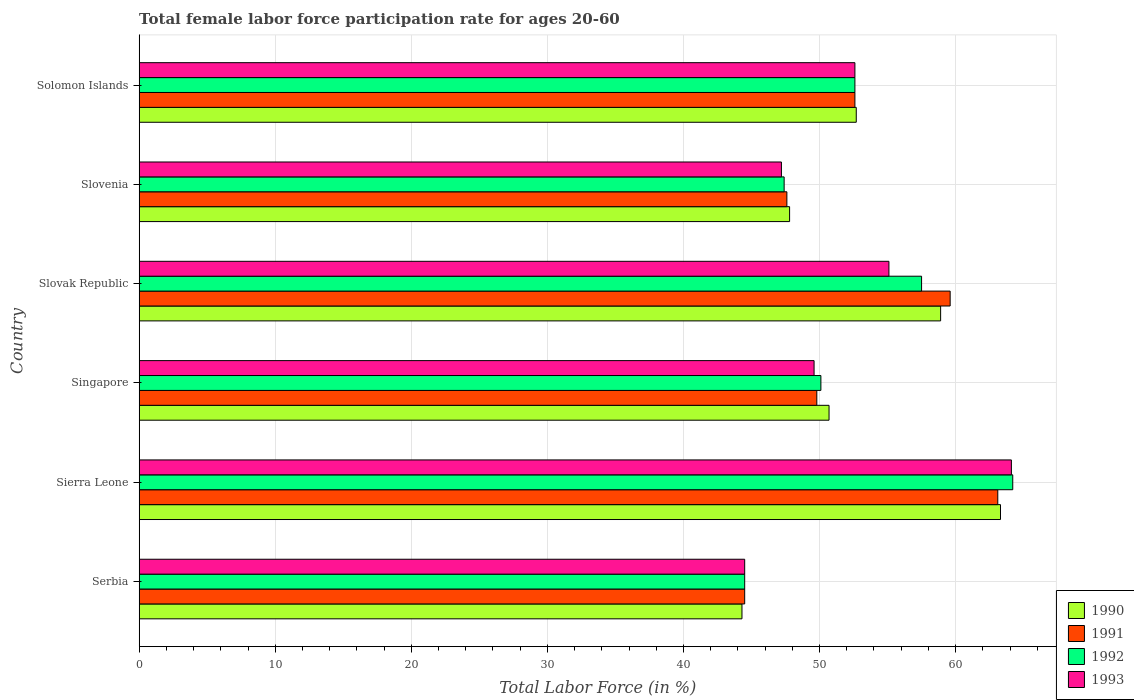How many bars are there on the 2nd tick from the top?
Your response must be concise. 4. What is the label of the 5th group of bars from the top?
Provide a succinct answer. Sierra Leone. What is the female labor force participation rate in 1991 in Singapore?
Provide a short and direct response. 49.8. Across all countries, what is the maximum female labor force participation rate in 1992?
Give a very brief answer. 64.2. Across all countries, what is the minimum female labor force participation rate in 1990?
Ensure brevity in your answer.  44.3. In which country was the female labor force participation rate in 1992 maximum?
Provide a short and direct response. Sierra Leone. In which country was the female labor force participation rate in 1990 minimum?
Give a very brief answer. Serbia. What is the total female labor force participation rate in 1991 in the graph?
Keep it short and to the point. 317.2. What is the difference between the female labor force participation rate in 1992 in Serbia and that in Sierra Leone?
Keep it short and to the point. -19.7. What is the difference between the female labor force participation rate in 1990 in Serbia and the female labor force participation rate in 1992 in Sierra Leone?
Provide a short and direct response. -19.9. What is the average female labor force participation rate in 1992 per country?
Make the answer very short. 52.72. What is the difference between the female labor force participation rate in 1990 and female labor force participation rate in 1991 in Serbia?
Give a very brief answer. -0.2. What is the ratio of the female labor force participation rate in 1993 in Sierra Leone to that in Solomon Islands?
Your response must be concise. 1.22. Is the female labor force participation rate in 1990 in Sierra Leone less than that in Solomon Islands?
Your answer should be compact. No. Is the difference between the female labor force participation rate in 1990 in Singapore and Slovenia greater than the difference between the female labor force participation rate in 1991 in Singapore and Slovenia?
Make the answer very short. Yes. What is the difference between the highest and the second highest female labor force participation rate in 1991?
Make the answer very short. 3.5. What is the difference between the highest and the lowest female labor force participation rate in 1990?
Give a very brief answer. 19. Is the sum of the female labor force participation rate in 1992 in Serbia and Slovenia greater than the maximum female labor force participation rate in 1993 across all countries?
Provide a short and direct response. Yes. What does the 1st bar from the bottom in Slovak Republic represents?
Your answer should be very brief. 1990. How many countries are there in the graph?
Keep it short and to the point. 6. Does the graph contain any zero values?
Provide a succinct answer. No. Does the graph contain grids?
Make the answer very short. Yes. Where does the legend appear in the graph?
Keep it short and to the point. Bottom right. How are the legend labels stacked?
Provide a succinct answer. Vertical. What is the title of the graph?
Give a very brief answer. Total female labor force participation rate for ages 20-60. What is the label or title of the X-axis?
Your answer should be very brief. Total Labor Force (in %). What is the label or title of the Y-axis?
Provide a succinct answer. Country. What is the Total Labor Force (in %) in 1990 in Serbia?
Keep it short and to the point. 44.3. What is the Total Labor Force (in %) in 1991 in Serbia?
Keep it short and to the point. 44.5. What is the Total Labor Force (in %) in 1992 in Serbia?
Your answer should be very brief. 44.5. What is the Total Labor Force (in %) in 1993 in Serbia?
Offer a terse response. 44.5. What is the Total Labor Force (in %) in 1990 in Sierra Leone?
Offer a very short reply. 63.3. What is the Total Labor Force (in %) in 1991 in Sierra Leone?
Provide a short and direct response. 63.1. What is the Total Labor Force (in %) in 1992 in Sierra Leone?
Your answer should be compact. 64.2. What is the Total Labor Force (in %) in 1993 in Sierra Leone?
Offer a terse response. 64.1. What is the Total Labor Force (in %) in 1990 in Singapore?
Give a very brief answer. 50.7. What is the Total Labor Force (in %) in 1991 in Singapore?
Make the answer very short. 49.8. What is the Total Labor Force (in %) of 1992 in Singapore?
Keep it short and to the point. 50.1. What is the Total Labor Force (in %) in 1993 in Singapore?
Your answer should be very brief. 49.6. What is the Total Labor Force (in %) of 1990 in Slovak Republic?
Ensure brevity in your answer.  58.9. What is the Total Labor Force (in %) in 1991 in Slovak Republic?
Your answer should be compact. 59.6. What is the Total Labor Force (in %) in 1992 in Slovak Republic?
Make the answer very short. 57.5. What is the Total Labor Force (in %) in 1993 in Slovak Republic?
Offer a very short reply. 55.1. What is the Total Labor Force (in %) of 1990 in Slovenia?
Give a very brief answer. 47.8. What is the Total Labor Force (in %) in 1991 in Slovenia?
Provide a short and direct response. 47.6. What is the Total Labor Force (in %) in 1992 in Slovenia?
Your response must be concise. 47.4. What is the Total Labor Force (in %) of 1993 in Slovenia?
Ensure brevity in your answer.  47.2. What is the Total Labor Force (in %) of 1990 in Solomon Islands?
Ensure brevity in your answer.  52.7. What is the Total Labor Force (in %) of 1991 in Solomon Islands?
Your answer should be very brief. 52.6. What is the Total Labor Force (in %) of 1992 in Solomon Islands?
Provide a succinct answer. 52.6. What is the Total Labor Force (in %) in 1993 in Solomon Islands?
Keep it short and to the point. 52.6. Across all countries, what is the maximum Total Labor Force (in %) in 1990?
Make the answer very short. 63.3. Across all countries, what is the maximum Total Labor Force (in %) in 1991?
Ensure brevity in your answer.  63.1. Across all countries, what is the maximum Total Labor Force (in %) in 1992?
Give a very brief answer. 64.2. Across all countries, what is the maximum Total Labor Force (in %) of 1993?
Ensure brevity in your answer.  64.1. Across all countries, what is the minimum Total Labor Force (in %) in 1990?
Ensure brevity in your answer.  44.3. Across all countries, what is the minimum Total Labor Force (in %) of 1991?
Your answer should be compact. 44.5. Across all countries, what is the minimum Total Labor Force (in %) of 1992?
Provide a succinct answer. 44.5. Across all countries, what is the minimum Total Labor Force (in %) in 1993?
Provide a succinct answer. 44.5. What is the total Total Labor Force (in %) of 1990 in the graph?
Ensure brevity in your answer.  317.7. What is the total Total Labor Force (in %) in 1991 in the graph?
Give a very brief answer. 317.2. What is the total Total Labor Force (in %) in 1992 in the graph?
Offer a terse response. 316.3. What is the total Total Labor Force (in %) in 1993 in the graph?
Ensure brevity in your answer.  313.1. What is the difference between the Total Labor Force (in %) in 1991 in Serbia and that in Sierra Leone?
Your answer should be very brief. -18.6. What is the difference between the Total Labor Force (in %) of 1992 in Serbia and that in Sierra Leone?
Provide a succinct answer. -19.7. What is the difference between the Total Labor Force (in %) of 1993 in Serbia and that in Sierra Leone?
Your response must be concise. -19.6. What is the difference between the Total Labor Force (in %) of 1990 in Serbia and that in Singapore?
Keep it short and to the point. -6.4. What is the difference between the Total Labor Force (in %) of 1991 in Serbia and that in Singapore?
Give a very brief answer. -5.3. What is the difference between the Total Labor Force (in %) of 1992 in Serbia and that in Singapore?
Offer a very short reply. -5.6. What is the difference between the Total Labor Force (in %) of 1990 in Serbia and that in Slovak Republic?
Keep it short and to the point. -14.6. What is the difference between the Total Labor Force (in %) in 1991 in Serbia and that in Slovak Republic?
Provide a succinct answer. -15.1. What is the difference between the Total Labor Force (in %) in 1993 in Serbia and that in Slovak Republic?
Offer a terse response. -10.6. What is the difference between the Total Labor Force (in %) of 1990 in Serbia and that in Slovenia?
Give a very brief answer. -3.5. What is the difference between the Total Labor Force (in %) of 1991 in Serbia and that in Slovenia?
Your answer should be compact. -3.1. What is the difference between the Total Labor Force (in %) of 1993 in Serbia and that in Slovenia?
Give a very brief answer. -2.7. What is the difference between the Total Labor Force (in %) in 1992 in Sierra Leone and that in Singapore?
Your response must be concise. 14.1. What is the difference between the Total Labor Force (in %) in 1993 in Sierra Leone and that in Singapore?
Offer a terse response. 14.5. What is the difference between the Total Labor Force (in %) of 1990 in Sierra Leone and that in Slovak Republic?
Your answer should be very brief. 4.4. What is the difference between the Total Labor Force (in %) in 1991 in Sierra Leone and that in Slovak Republic?
Offer a very short reply. 3.5. What is the difference between the Total Labor Force (in %) in 1990 in Sierra Leone and that in Solomon Islands?
Give a very brief answer. 10.6. What is the difference between the Total Labor Force (in %) of 1991 in Sierra Leone and that in Solomon Islands?
Offer a terse response. 10.5. What is the difference between the Total Labor Force (in %) in 1993 in Sierra Leone and that in Solomon Islands?
Give a very brief answer. 11.5. What is the difference between the Total Labor Force (in %) of 1990 in Singapore and that in Slovak Republic?
Offer a very short reply. -8.2. What is the difference between the Total Labor Force (in %) in 1991 in Singapore and that in Slovak Republic?
Your answer should be compact. -9.8. What is the difference between the Total Labor Force (in %) in 1992 in Singapore and that in Slovak Republic?
Ensure brevity in your answer.  -7.4. What is the difference between the Total Labor Force (in %) of 1990 in Singapore and that in Slovenia?
Your answer should be very brief. 2.9. What is the difference between the Total Labor Force (in %) in 1991 in Singapore and that in Slovenia?
Keep it short and to the point. 2.2. What is the difference between the Total Labor Force (in %) of 1991 in Singapore and that in Solomon Islands?
Offer a very short reply. -2.8. What is the difference between the Total Labor Force (in %) of 1992 in Singapore and that in Solomon Islands?
Provide a succinct answer. -2.5. What is the difference between the Total Labor Force (in %) in 1990 in Slovak Republic and that in Slovenia?
Your answer should be compact. 11.1. What is the difference between the Total Labor Force (in %) in 1992 in Slovak Republic and that in Slovenia?
Your answer should be compact. 10.1. What is the difference between the Total Labor Force (in %) of 1993 in Slovak Republic and that in Slovenia?
Ensure brevity in your answer.  7.9. What is the difference between the Total Labor Force (in %) of 1992 in Slovak Republic and that in Solomon Islands?
Your answer should be compact. 4.9. What is the difference between the Total Labor Force (in %) in 1993 in Slovak Republic and that in Solomon Islands?
Keep it short and to the point. 2.5. What is the difference between the Total Labor Force (in %) in 1990 in Slovenia and that in Solomon Islands?
Keep it short and to the point. -4.9. What is the difference between the Total Labor Force (in %) of 1991 in Slovenia and that in Solomon Islands?
Your answer should be compact. -5. What is the difference between the Total Labor Force (in %) in 1992 in Slovenia and that in Solomon Islands?
Your answer should be compact. -5.2. What is the difference between the Total Labor Force (in %) of 1990 in Serbia and the Total Labor Force (in %) of 1991 in Sierra Leone?
Offer a very short reply. -18.8. What is the difference between the Total Labor Force (in %) of 1990 in Serbia and the Total Labor Force (in %) of 1992 in Sierra Leone?
Offer a terse response. -19.9. What is the difference between the Total Labor Force (in %) of 1990 in Serbia and the Total Labor Force (in %) of 1993 in Sierra Leone?
Offer a very short reply. -19.8. What is the difference between the Total Labor Force (in %) in 1991 in Serbia and the Total Labor Force (in %) in 1992 in Sierra Leone?
Keep it short and to the point. -19.7. What is the difference between the Total Labor Force (in %) in 1991 in Serbia and the Total Labor Force (in %) in 1993 in Sierra Leone?
Give a very brief answer. -19.6. What is the difference between the Total Labor Force (in %) of 1992 in Serbia and the Total Labor Force (in %) of 1993 in Sierra Leone?
Offer a very short reply. -19.6. What is the difference between the Total Labor Force (in %) in 1990 in Serbia and the Total Labor Force (in %) in 1991 in Singapore?
Your answer should be very brief. -5.5. What is the difference between the Total Labor Force (in %) of 1990 in Serbia and the Total Labor Force (in %) of 1992 in Singapore?
Provide a short and direct response. -5.8. What is the difference between the Total Labor Force (in %) in 1991 in Serbia and the Total Labor Force (in %) in 1992 in Singapore?
Your answer should be very brief. -5.6. What is the difference between the Total Labor Force (in %) of 1991 in Serbia and the Total Labor Force (in %) of 1993 in Singapore?
Give a very brief answer. -5.1. What is the difference between the Total Labor Force (in %) in 1990 in Serbia and the Total Labor Force (in %) in 1991 in Slovak Republic?
Provide a succinct answer. -15.3. What is the difference between the Total Labor Force (in %) of 1990 in Serbia and the Total Labor Force (in %) of 1993 in Slovak Republic?
Keep it short and to the point. -10.8. What is the difference between the Total Labor Force (in %) in 1991 in Serbia and the Total Labor Force (in %) in 1992 in Slovak Republic?
Provide a succinct answer. -13. What is the difference between the Total Labor Force (in %) in 1991 in Serbia and the Total Labor Force (in %) in 1993 in Slovak Republic?
Your response must be concise. -10.6. What is the difference between the Total Labor Force (in %) in 1992 in Serbia and the Total Labor Force (in %) in 1993 in Slovak Republic?
Ensure brevity in your answer.  -10.6. What is the difference between the Total Labor Force (in %) of 1990 in Serbia and the Total Labor Force (in %) of 1992 in Slovenia?
Your response must be concise. -3.1. What is the difference between the Total Labor Force (in %) in 1990 in Serbia and the Total Labor Force (in %) in 1993 in Slovenia?
Offer a very short reply. -2.9. What is the difference between the Total Labor Force (in %) in 1992 in Serbia and the Total Labor Force (in %) in 1993 in Slovenia?
Give a very brief answer. -2.7. What is the difference between the Total Labor Force (in %) in 1990 in Serbia and the Total Labor Force (in %) in 1992 in Solomon Islands?
Your answer should be compact. -8.3. What is the difference between the Total Labor Force (in %) in 1991 in Serbia and the Total Labor Force (in %) in 1993 in Solomon Islands?
Provide a short and direct response. -8.1. What is the difference between the Total Labor Force (in %) of 1992 in Serbia and the Total Labor Force (in %) of 1993 in Solomon Islands?
Your answer should be very brief. -8.1. What is the difference between the Total Labor Force (in %) in 1990 in Sierra Leone and the Total Labor Force (in %) in 1991 in Singapore?
Your answer should be very brief. 13.5. What is the difference between the Total Labor Force (in %) in 1991 in Sierra Leone and the Total Labor Force (in %) in 1993 in Singapore?
Ensure brevity in your answer.  13.5. What is the difference between the Total Labor Force (in %) in 1992 in Sierra Leone and the Total Labor Force (in %) in 1993 in Singapore?
Your response must be concise. 14.6. What is the difference between the Total Labor Force (in %) of 1990 in Sierra Leone and the Total Labor Force (in %) of 1992 in Slovak Republic?
Your response must be concise. 5.8. What is the difference between the Total Labor Force (in %) in 1990 in Sierra Leone and the Total Labor Force (in %) in 1993 in Slovak Republic?
Make the answer very short. 8.2. What is the difference between the Total Labor Force (in %) of 1992 in Sierra Leone and the Total Labor Force (in %) of 1993 in Slovak Republic?
Keep it short and to the point. 9.1. What is the difference between the Total Labor Force (in %) of 1990 in Sierra Leone and the Total Labor Force (in %) of 1992 in Slovenia?
Give a very brief answer. 15.9. What is the difference between the Total Labor Force (in %) of 1990 in Sierra Leone and the Total Labor Force (in %) of 1993 in Slovenia?
Your response must be concise. 16.1. What is the difference between the Total Labor Force (in %) of 1991 in Sierra Leone and the Total Labor Force (in %) of 1992 in Slovenia?
Keep it short and to the point. 15.7. What is the difference between the Total Labor Force (in %) of 1990 in Sierra Leone and the Total Labor Force (in %) of 1991 in Solomon Islands?
Make the answer very short. 10.7. What is the difference between the Total Labor Force (in %) in 1990 in Sierra Leone and the Total Labor Force (in %) in 1993 in Solomon Islands?
Give a very brief answer. 10.7. What is the difference between the Total Labor Force (in %) of 1991 in Sierra Leone and the Total Labor Force (in %) of 1993 in Solomon Islands?
Give a very brief answer. 10.5. What is the difference between the Total Labor Force (in %) in 1990 in Singapore and the Total Labor Force (in %) in 1991 in Slovak Republic?
Keep it short and to the point. -8.9. What is the difference between the Total Labor Force (in %) in 1990 in Singapore and the Total Labor Force (in %) in 1992 in Slovak Republic?
Make the answer very short. -6.8. What is the difference between the Total Labor Force (in %) in 1990 in Singapore and the Total Labor Force (in %) in 1993 in Slovak Republic?
Give a very brief answer. -4.4. What is the difference between the Total Labor Force (in %) in 1991 in Singapore and the Total Labor Force (in %) in 1992 in Slovak Republic?
Offer a terse response. -7.7. What is the difference between the Total Labor Force (in %) in 1991 in Singapore and the Total Labor Force (in %) in 1993 in Slovak Republic?
Your answer should be very brief. -5.3. What is the difference between the Total Labor Force (in %) of 1992 in Singapore and the Total Labor Force (in %) of 1993 in Slovak Republic?
Your answer should be compact. -5. What is the difference between the Total Labor Force (in %) in 1990 in Singapore and the Total Labor Force (in %) in 1991 in Slovenia?
Your answer should be very brief. 3.1. What is the difference between the Total Labor Force (in %) of 1990 in Singapore and the Total Labor Force (in %) of 1992 in Slovenia?
Keep it short and to the point. 3.3. What is the difference between the Total Labor Force (in %) of 1990 in Singapore and the Total Labor Force (in %) of 1993 in Slovenia?
Ensure brevity in your answer.  3.5. What is the difference between the Total Labor Force (in %) in 1991 in Singapore and the Total Labor Force (in %) in 1992 in Slovenia?
Make the answer very short. 2.4. What is the difference between the Total Labor Force (in %) of 1990 in Singapore and the Total Labor Force (in %) of 1991 in Solomon Islands?
Offer a very short reply. -1.9. What is the difference between the Total Labor Force (in %) of 1991 in Singapore and the Total Labor Force (in %) of 1992 in Solomon Islands?
Make the answer very short. -2.8. What is the difference between the Total Labor Force (in %) in 1991 in Singapore and the Total Labor Force (in %) in 1993 in Solomon Islands?
Your response must be concise. -2.8. What is the difference between the Total Labor Force (in %) in 1992 in Singapore and the Total Labor Force (in %) in 1993 in Solomon Islands?
Ensure brevity in your answer.  -2.5. What is the difference between the Total Labor Force (in %) in 1990 in Slovak Republic and the Total Labor Force (in %) in 1993 in Slovenia?
Your answer should be very brief. 11.7. What is the difference between the Total Labor Force (in %) of 1990 in Slovak Republic and the Total Labor Force (in %) of 1991 in Solomon Islands?
Ensure brevity in your answer.  6.3. What is the difference between the Total Labor Force (in %) of 1990 in Slovak Republic and the Total Labor Force (in %) of 1992 in Solomon Islands?
Your answer should be very brief. 6.3. What is the difference between the Total Labor Force (in %) in 1990 in Slovak Republic and the Total Labor Force (in %) in 1993 in Solomon Islands?
Provide a succinct answer. 6.3. What is the difference between the Total Labor Force (in %) in 1990 in Slovenia and the Total Labor Force (in %) in 1991 in Solomon Islands?
Provide a short and direct response. -4.8. What is the difference between the Total Labor Force (in %) of 1990 in Slovenia and the Total Labor Force (in %) of 1992 in Solomon Islands?
Offer a very short reply. -4.8. What is the difference between the Total Labor Force (in %) of 1990 in Slovenia and the Total Labor Force (in %) of 1993 in Solomon Islands?
Keep it short and to the point. -4.8. What is the difference between the Total Labor Force (in %) in 1992 in Slovenia and the Total Labor Force (in %) in 1993 in Solomon Islands?
Your answer should be compact. -5.2. What is the average Total Labor Force (in %) of 1990 per country?
Your answer should be very brief. 52.95. What is the average Total Labor Force (in %) in 1991 per country?
Ensure brevity in your answer.  52.87. What is the average Total Labor Force (in %) of 1992 per country?
Give a very brief answer. 52.72. What is the average Total Labor Force (in %) in 1993 per country?
Keep it short and to the point. 52.18. What is the difference between the Total Labor Force (in %) in 1990 and Total Labor Force (in %) in 1991 in Serbia?
Your response must be concise. -0.2. What is the difference between the Total Labor Force (in %) of 1990 and Total Labor Force (in %) of 1993 in Serbia?
Provide a succinct answer. -0.2. What is the difference between the Total Labor Force (in %) in 1991 and Total Labor Force (in %) in 1992 in Serbia?
Keep it short and to the point. 0. What is the difference between the Total Labor Force (in %) of 1990 and Total Labor Force (in %) of 1992 in Sierra Leone?
Your answer should be very brief. -0.9. What is the difference between the Total Labor Force (in %) of 1990 and Total Labor Force (in %) of 1993 in Sierra Leone?
Offer a very short reply. -0.8. What is the difference between the Total Labor Force (in %) in 1991 and Total Labor Force (in %) in 1992 in Sierra Leone?
Ensure brevity in your answer.  -1.1. What is the difference between the Total Labor Force (in %) of 1992 and Total Labor Force (in %) of 1993 in Sierra Leone?
Offer a very short reply. 0.1. What is the difference between the Total Labor Force (in %) of 1990 and Total Labor Force (in %) of 1992 in Singapore?
Offer a very short reply. 0.6. What is the difference between the Total Labor Force (in %) in 1991 and Total Labor Force (in %) in 1992 in Singapore?
Provide a succinct answer. -0.3. What is the difference between the Total Labor Force (in %) of 1991 and Total Labor Force (in %) of 1993 in Singapore?
Make the answer very short. 0.2. What is the difference between the Total Labor Force (in %) of 1991 and Total Labor Force (in %) of 1993 in Slovak Republic?
Give a very brief answer. 4.5. What is the difference between the Total Labor Force (in %) of 1990 and Total Labor Force (in %) of 1991 in Slovenia?
Make the answer very short. 0.2. What is the difference between the Total Labor Force (in %) of 1991 and Total Labor Force (in %) of 1992 in Slovenia?
Give a very brief answer. 0.2. What is the difference between the Total Labor Force (in %) of 1991 and Total Labor Force (in %) of 1993 in Slovenia?
Offer a very short reply. 0.4. What is the difference between the Total Labor Force (in %) in 1990 and Total Labor Force (in %) in 1992 in Solomon Islands?
Your answer should be very brief. 0.1. What is the difference between the Total Labor Force (in %) of 1991 and Total Labor Force (in %) of 1992 in Solomon Islands?
Your response must be concise. 0. What is the difference between the Total Labor Force (in %) in 1991 and Total Labor Force (in %) in 1993 in Solomon Islands?
Offer a terse response. 0. What is the difference between the Total Labor Force (in %) of 1992 and Total Labor Force (in %) of 1993 in Solomon Islands?
Keep it short and to the point. 0. What is the ratio of the Total Labor Force (in %) in 1990 in Serbia to that in Sierra Leone?
Give a very brief answer. 0.7. What is the ratio of the Total Labor Force (in %) in 1991 in Serbia to that in Sierra Leone?
Provide a succinct answer. 0.71. What is the ratio of the Total Labor Force (in %) of 1992 in Serbia to that in Sierra Leone?
Ensure brevity in your answer.  0.69. What is the ratio of the Total Labor Force (in %) in 1993 in Serbia to that in Sierra Leone?
Ensure brevity in your answer.  0.69. What is the ratio of the Total Labor Force (in %) of 1990 in Serbia to that in Singapore?
Offer a very short reply. 0.87. What is the ratio of the Total Labor Force (in %) in 1991 in Serbia to that in Singapore?
Your answer should be compact. 0.89. What is the ratio of the Total Labor Force (in %) of 1992 in Serbia to that in Singapore?
Provide a succinct answer. 0.89. What is the ratio of the Total Labor Force (in %) in 1993 in Serbia to that in Singapore?
Your answer should be very brief. 0.9. What is the ratio of the Total Labor Force (in %) in 1990 in Serbia to that in Slovak Republic?
Offer a very short reply. 0.75. What is the ratio of the Total Labor Force (in %) in 1991 in Serbia to that in Slovak Republic?
Provide a succinct answer. 0.75. What is the ratio of the Total Labor Force (in %) in 1992 in Serbia to that in Slovak Republic?
Give a very brief answer. 0.77. What is the ratio of the Total Labor Force (in %) of 1993 in Serbia to that in Slovak Republic?
Provide a succinct answer. 0.81. What is the ratio of the Total Labor Force (in %) of 1990 in Serbia to that in Slovenia?
Offer a very short reply. 0.93. What is the ratio of the Total Labor Force (in %) of 1991 in Serbia to that in Slovenia?
Your response must be concise. 0.93. What is the ratio of the Total Labor Force (in %) in 1992 in Serbia to that in Slovenia?
Offer a terse response. 0.94. What is the ratio of the Total Labor Force (in %) of 1993 in Serbia to that in Slovenia?
Provide a succinct answer. 0.94. What is the ratio of the Total Labor Force (in %) of 1990 in Serbia to that in Solomon Islands?
Offer a terse response. 0.84. What is the ratio of the Total Labor Force (in %) of 1991 in Serbia to that in Solomon Islands?
Make the answer very short. 0.85. What is the ratio of the Total Labor Force (in %) in 1992 in Serbia to that in Solomon Islands?
Your response must be concise. 0.85. What is the ratio of the Total Labor Force (in %) in 1993 in Serbia to that in Solomon Islands?
Provide a short and direct response. 0.85. What is the ratio of the Total Labor Force (in %) of 1990 in Sierra Leone to that in Singapore?
Make the answer very short. 1.25. What is the ratio of the Total Labor Force (in %) in 1991 in Sierra Leone to that in Singapore?
Offer a very short reply. 1.27. What is the ratio of the Total Labor Force (in %) in 1992 in Sierra Leone to that in Singapore?
Keep it short and to the point. 1.28. What is the ratio of the Total Labor Force (in %) in 1993 in Sierra Leone to that in Singapore?
Keep it short and to the point. 1.29. What is the ratio of the Total Labor Force (in %) in 1990 in Sierra Leone to that in Slovak Republic?
Give a very brief answer. 1.07. What is the ratio of the Total Labor Force (in %) in 1991 in Sierra Leone to that in Slovak Republic?
Your answer should be compact. 1.06. What is the ratio of the Total Labor Force (in %) of 1992 in Sierra Leone to that in Slovak Republic?
Provide a short and direct response. 1.12. What is the ratio of the Total Labor Force (in %) of 1993 in Sierra Leone to that in Slovak Republic?
Make the answer very short. 1.16. What is the ratio of the Total Labor Force (in %) of 1990 in Sierra Leone to that in Slovenia?
Offer a terse response. 1.32. What is the ratio of the Total Labor Force (in %) of 1991 in Sierra Leone to that in Slovenia?
Keep it short and to the point. 1.33. What is the ratio of the Total Labor Force (in %) in 1992 in Sierra Leone to that in Slovenia?
Give a very brief answer. 1.35. What is the ratio of the Total Labor Force (in %) in 1993 in Sierra Leone to that in Slovenia?
Offer a terse response. 1.36. What is the ratio of the Total Labor Force (in %) of 1990 in Sierra Leone to that in Solomon Islands?
Your answer should be compact. 1.2. What is the ratio of the Total Labor Force (in %) of 1991 in Sierra Leone to that in Solomon Islands?
Ensure brevity in your answer.  1.2. What is the ratio of the Total Labor Force (in %) of 1992 in Sierra Leone to that in Solomon Islands?
Make the answer very short. 1.22. What is the ratio of the Total Labor Force (in %) in 1993 in Sierra Leone to that in Solomon Islands?
Keep it short and to the point. 1.22. What is the ratio of the Total Labor Force (in %) of 1990 in Singapore to that in Slovak Republic?
Provide a short and direct response. 0.86. What is the ratio of the Total Labor Force (in %) in 1991 in Singapore to that in Slovak Republic?
Offer a very short reply. 0.84. What is the ratio of the Total Labor Force (in %) of 1992 in Singapore to that in Slovak Republic?
Offer a terse response. 0.87. What is the ratio of the Total Labor Force (in %) in 1993 in Singapore to that in Slovak Republic?
Make the answer very short. 0.9. What is the ratio of the Total Labor Force (in %) in 1990 in Singapore to that in Slovenia?
Your response must be concise. 1.06. What is the ratio of the Total Labor Force (in %) in 1991 in Singapore to that in Slovenia?
Provide a succinct answer. 1.05. What is the ratio of the Total Labor Force (in %) in 1992 in Singapore to that in Slovenia?
Provide a succinct answer. 1.06. What is the ratio of the Total Labor Force (in %) of 1993 in Singapore to that in Slovenia?
Provide a short and direct response. 1.05. What is the ratio of the Total Labor Force (in %) in 1990 in Singapore to that in Solomon Islands?
Make the answer very short. 0.96. What is the ratio of the Total Labor Force (in %) in 1991 in Singapore to that in Solomon Islands?
Provide a short and direct response. 0.95. What is the ratio of the Total Labor Force (in %) of 1992 in Singapore to that in Solomon Islands?
Give a very brief answer. 0.95. What is the ratio of the Total Labor Force (in %) of 1993 in Singapore to that in Solomon Islands?
Offer a very short reply. 0.94. What is the ratio of the Total Labor Force (in %) in 1990 in Slovak Republic to that in Slovenia?
Keep it short and to the point. 1.23. What is the ratio of the Total Labor Force (in %) in 1991 in Slovak Republic to that in Slovenia?
Offer a terse response. 1.25. What is the ratio of the Total Labor Force (in %) of 1992 in Slovak Republic to that in Slovenia?
Provide a succinct answer. 1.21. What is the ratio of the Total Labor Force (in %) in 1993 in Slovak Republic to that in Slovenia?
Your answer should be compact. 1.17. What is the ratio of the Total Labor Force (in %) of 1990 in Slovak Republic to that in Solomon Islands?
Make the answer very short. 1.12. What is the ratio of the Total Labor Force (in %) of 1991 in Slovak Republic to that in Solomon Islands?
Make the answer very short. 1.13. What is the ratio of the Total Labor Force (in %) of 1992 in Slovak Republic to that in Solomon Islands?
Offer a very short reply. 1.09. What is the ratio of the Total Labor Force (in %) in 1993 in Slovak Republic to that in Solomon Islands?
Offer a terse response. 1.05. What is the ratio of the Total Labor Force (in %) of 1990 in Slovenia to that in Solomon Islands?
Keep it short and to the point. 0.91. What is the ratio of the Total Labor Force (in %) in 1991 in Slovenia to that in Solomon Islands?
Offer a very short reply. 0.9. What is the ratio of the Total Labor Force (in %) in 1992 in Slovenia to that in Solomon Islands?
Your answer should be very brief. 0.9. What is the ratio of the Total Labor Force (in %) of 1993 in Slovenia to that in Solomon Islands?
Ensure brevity in your answer.  0.9. What is the difference between the highest and the second highest Total Labor Force (in %) of 1992?
Give a very brief answer. 6.7. What is the difference between the highest and the lowest Total Labor Force (in %) in 1990?
Provide a succinct answer. 19. What is the difference between the highest and the lowest Total Labor Force (in %) of 1991?
Your response must be concise. 18.6. What is the difference between the highest and the lowest Total Labor Force (in %) of 1992?
Make the answer very short. 19.7. What is the difference between the highest and the lowest Total Labor Force (in %) in 1993?
Your response must be concise. 19.6. 